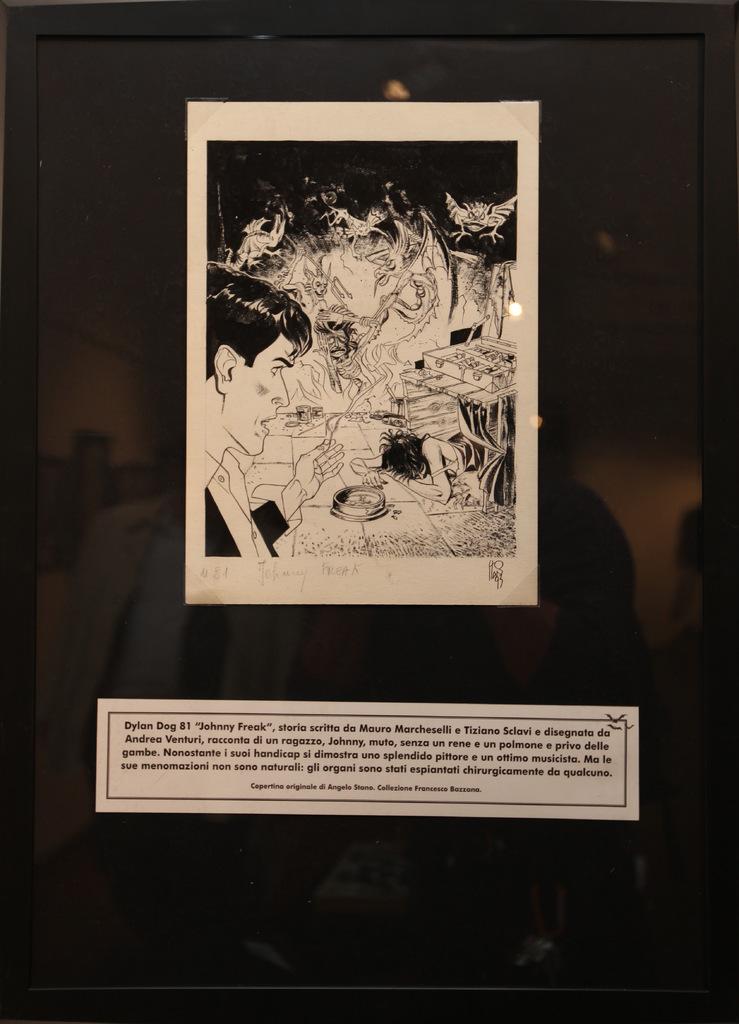Is this a picture from a comic?
Provide a short and direct response. Answering does not require reading text in the image. What is the name of the drawing?
Make the answer very short. Johnny freak. 